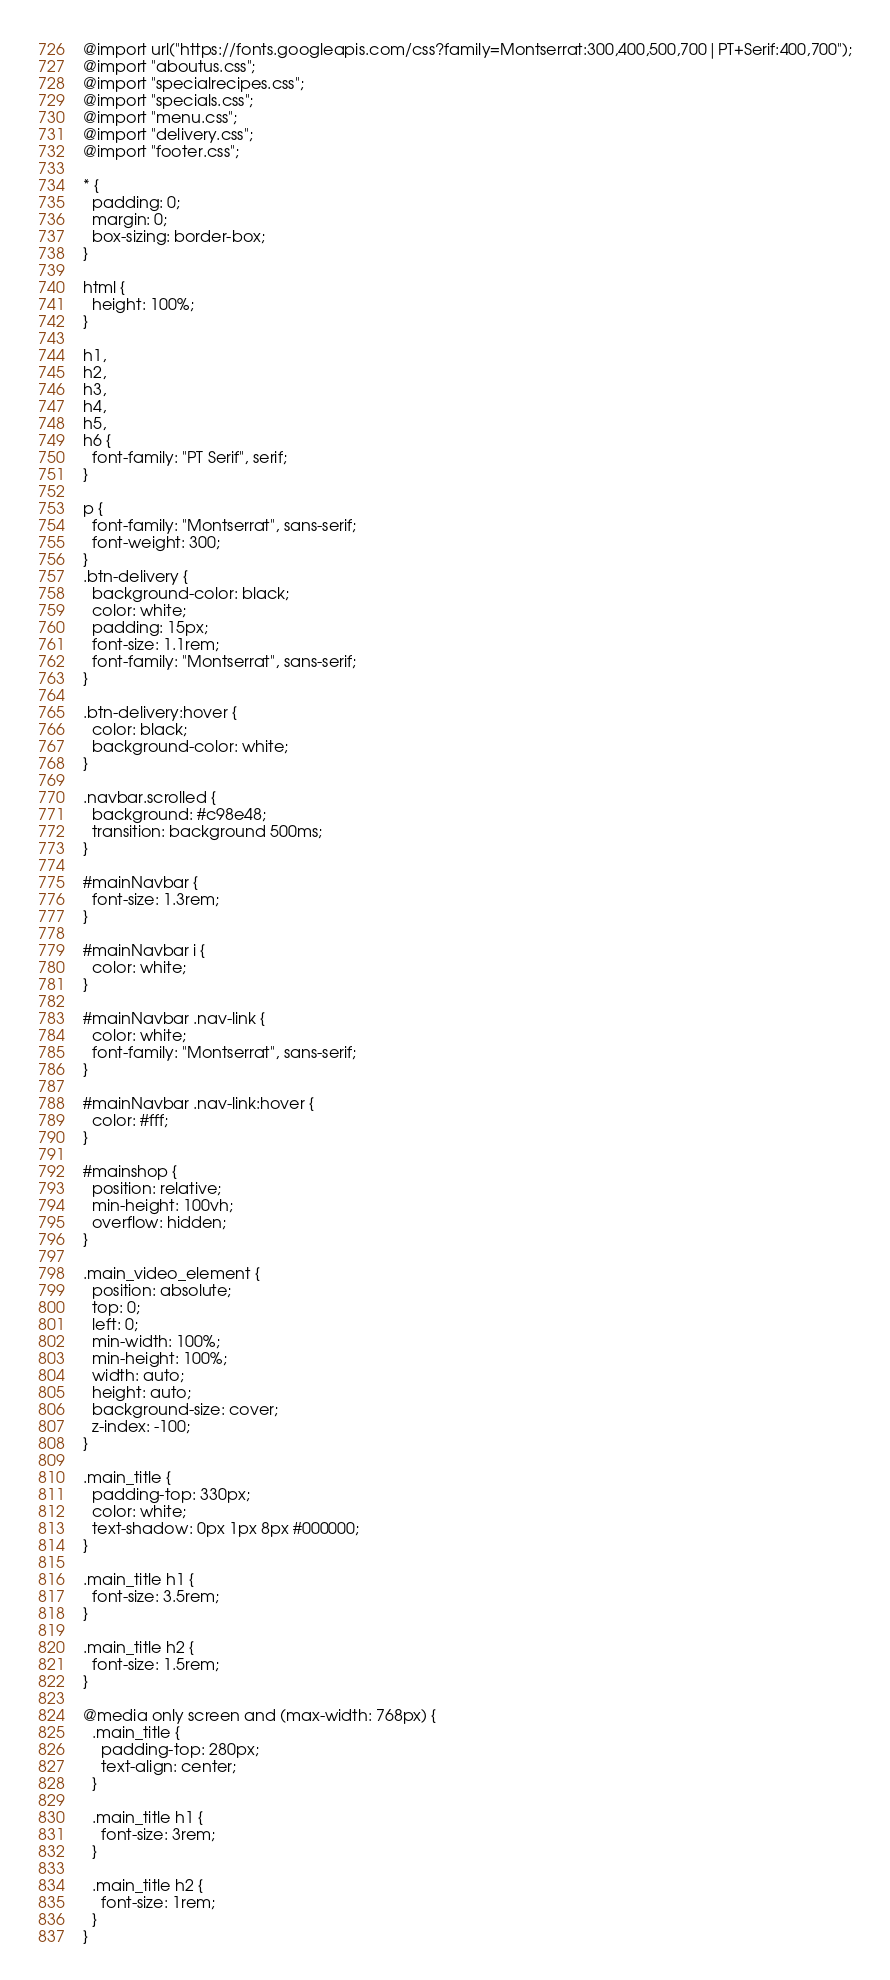<code> <loc_0><loc_0><loc_500><loc_500><_CSS_>@import url("https://fonts.googleapis.com/css?family=Montserrat:300,400,500,700|PT+Serif:400,700");
@import "aboutus.css";
@import "specialrecipes.css";
@import "specials.css";
@import "menu.css";
@import "delivery.css";
@import "footer.css";

* {
  padding: 0;
  margin: 0;
  box-sizing: border-box;
}

html {
  height: 100%;
}

h1,
h2,
h3,
h4,
h5,
h6 {
  font-family: "PT Serif", serif;
}

p {
  font-family: "Montserrat", sans-serif;
  font-weight: 300;
}
.btn-delivery {
  background-color: black;
  color: white;
  padding: 15px;
  font-size: 1.1rem;
  font-family: "Montserrat", sans-serif;
}

.btn-delivery:hover {
  color: black;
  background-color: white;
}

.navbar.scrolled {
  background: #c98e48;
  transition: background 500ms;
}

#mainNavbar {
  font-size: 1.3rem;
}

#mainNavbar i {
  color: white;
}

#mainNavbar .nav-link {
  color: white;
  font-family: "Montserrat", sans-serif;
}

#mainNavbar .nav-link:hover {
  color: #fff;
}

#mainshop {
  position: relative;
  min-height: 100vh;
  overflow: hidden;
}

.main_video_element {
  position: absolute;
  top: 0;
  left: 0;
  min-width: 100%;
  min-height: 100%;
  width: auto;
  height: auto;
  background-size: cover;
  z-index: -100;
}

.main_title {
  padding-top: 330px;
  color: white;
  text-shadow: 0px 1px 8px #000000;
}

.main_title h1 {
  font-size: 3.5rem;
}

.main_title h2 {
  font-size: 1.5rem;
}

@media only screen and (max-width: 768px) {
  .main_title {
    padding-top: 280px;
    text-align: center;
  }

  .main_title h1 {
    font-size: 3rem;
  }

  .main_title h2 {
    font-size: 1rem;
  }
}
</code> 